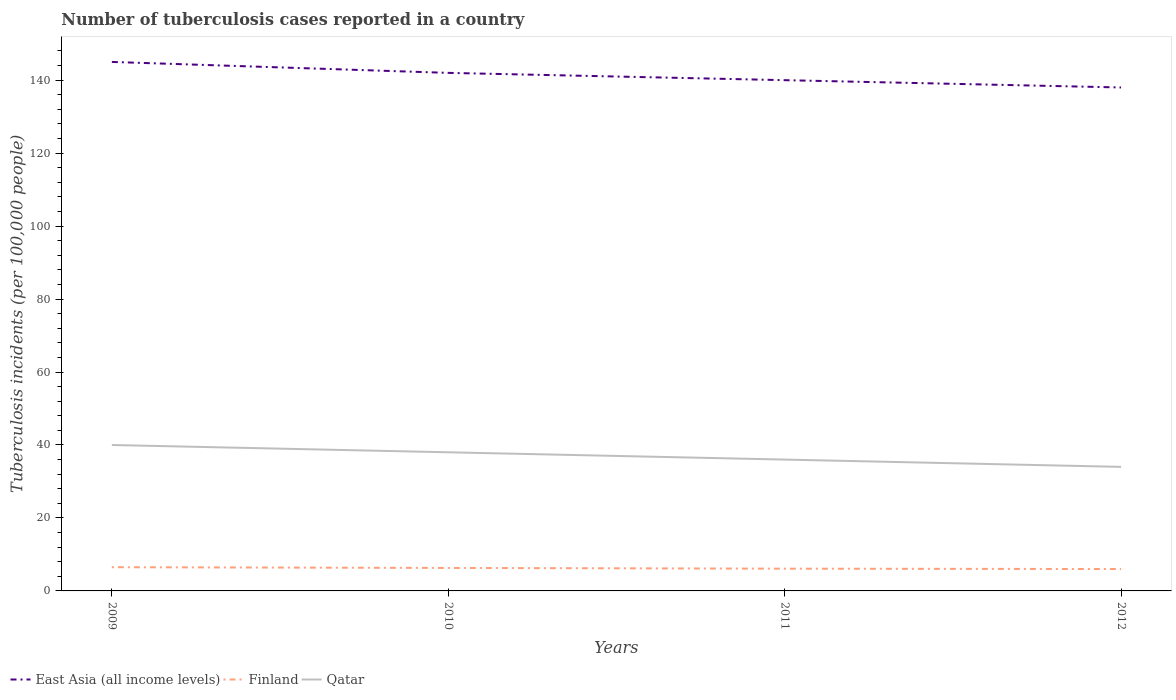Across all years, what is the maximum number of tuberculosis cases reported in in East Asia (all income levels)?
Give a very brief answer. 138. In which year was the number of tuberculosis cases reported in in Finland maximum?
Offer a very short reply. 2012. What is the difference between the highest and the second highest number of tuberculosis cases reported in in Finland?
Make the answer very short. 0.5. What is the difference between the highest and the lowest number of tuberculosis cases reported in in East Asia (all income levels)?
Provide a succinct answer. 2. How many lines are there?
Offer a very short reply. 3. Does the graph contain any zero values?
Provide a succinct answer. No. Does the graph contain grids?
Provide a succinct answer. No. Where does the legend appear in the graph?
Give a very brief answer. Bottom left. What is the title of the graph?
Your answer should be compact. Number of tuberculosis cases reported in a country. What is the label or title of the X-axis?
Keep it short and to the point. Years. What is the label or title of the Y-axis?
Offer a terse response. Tuberculosis incidents (per 100,0 people). What is the Tuberculosis incidents (per 100,000 people) of East Asia (all income levels) in 2009?
Give a very brief answer. 145. What is the Tuberculosis incidents (per 100,000 people) in Finland in 2009?
Provide a short and direct response. 6.5. What is the Tuberculosis incidents (per 100,000 people) of East Asia (all income levels) in 2010?
Your response must be concise. 142. What is the Tuberculosis incidents (per 100,000 people) of Finland in 2010?
Offer a very short reply. 6.3. What is the Tuberculosis incidents (per 100,000 people) of Qatar in 2010?
Offer a terse response. 38. What is the Tuberculosis incidents (per 100,000 people) in East Asia (all income levels) in 2011?
Give a very brief answer. 140. What is the Tuberculosis incidents (per 100,000 people) in East Asia (all income levels) in 2012?
Give a very brief answer. 138. Across all years, what is the maximum Tuberculosis incidents (per 100,000 people) in East Asia (all income levels)?
Offer a terse response. 145. Across all years, what is the maximum Tuberculosis incidents (per 100,000 people) in Qatar?
Provide a short and direct response. 40. Across all years, what is the minimum Tuberculosis incidents (per 100,000 people) of East Asia (all income levels)?
Provide a short and direct response. 138. Across all years, what is the minimum Tuberculosis incidents (per 100,000 people) of Finland?
Offer a very short reply. 6. Across all years, what is the minimum Tuberculosis incidents (per 100,000 people) of Qatar?
Keep it short and to the point. 34. What is the total Tuberculosis incidents (per 100,000 people) of East Asia (all income levels) in the graph?
Offer a very short reply. 565. What is the total Tuberculosis incidents (per 100,000 people) of Finland in the graph?
Offer a very short reply. 24.9. What is the total Tuberculosis incidents (per 100,000 people) in Qatar in the graph?
Your answer should be compact. 148. What is the difference between the Tuberculosis incidents (per 100,000 people) in Finland in 2009 and that in 2010?
Give a very brief answer. 0.2. What is the difference between the Tuberculosis incidents (per 100,000 people) of Qatar in 2009 and that in 2010?
Give a very brief answer. 2. What is the difference between the Tuberculosis incidents (per 100,000 people) in East Asia (all income levels) in 2009 and that in 2011?
Ensure brevity in your answer.  5. What is the difference between the Tuberculosis incidents (per 100,000 people) of Finland in 2009 and that in 2011?
Provide a succinct answer. 0.4. What is the difference between the Tuberculosis incidents (per 100,000 people) of Finland in 2009 and that in 2012?
Your answer should be compact. 0.5. What is the difference between the Tuberculosis incidents (per 100,000 people) in Qatar in 2009 and that in 2012?
Offer a very short reply. 6. What is the difference between the Tuberculosis incidents (per 100,000 people) in Finland in 2010 and that in 2011?
Give a very brief answer. 0.2. What is the difference between the Tuberculosis incidents (per 100,000 people) of Qatar in 2010 and that in 2011?
Your response must be concise. 2. What is the difference between the Tuberculosis incidents (per 100,000 people) of East Asia (all income levels) in 2011 and that in 2012?
Provide a short and direct response. 2. What is the difference between the Tuberculosis incidents (per 100,000 people) in Finland in 2011 and that in 2012?
Your response must be concise. 0.1. What is the difference between the Tuberculosis incidents (per 100,000 people) in Qatar in 2011 and that in 2012?
Offer a terse response. 2. What is the difference between the Tuberculosis incidents (per 100,000 people) of East Asia (all income levels) in 2009 and the Tuberculosis incidents (per 100,000 people) of Finland in 2010?
Your answer should be compact. 138.7. What is the difference between the Tuberculosis incidents (per 100,000 people) of East Asia (all income levels) in 2009 and the Tuberculosis incidents (per 100,000 people) of Qatar in 2010?
Ensure brevity in your answer.  107. What is the difference between the Tuberculosis incidents (per 100,000 people) of Finland in 2009 and the Tuberculosis incidents (per 100,000 people) of Qatar in 2010?
Keep it short and to the point. -31.5. What is the difference between the Tuberculosis incidents (per 100,000 people) in East Asia (all income levels) in 2009 and the Tuberculosis incidents (per 100,000 people) in Finland in 2011?
Provide a succinct answer. 138.9. What is the difference between the Tuberculosis incidents (per 100,000 people) in East Asia (all income levels) in 2009 and the Tuberculosis incidents (per 100,000 people) in Qatar in 2011?
Make the answer very short. 109. What is the difference between the Tuberculosis incidents (per 100,000 people) in Finland in 2009 and the Tuberculosis incidents (per 100,000 people) in Qatar in 2011?
Your answer should be compact. -29.5. What is the difference between the Tuberculosis incidents (per 100,000 people) of East Asia (all income levels) in 2009 and the Tuberculosis incidents (per 100,000 people) of Finland in 2012?
Make the answer very short. 139. What is the difference between the Tuberculosis incidents (per 100,000 people) in East Asia (all income levels) in 2009 and the Tuberculosis incidents (per 100,000 people) in Qatar in 2012?
Ensure brevity in your answer.  111. What is the difference between the Tuberculosis incidents (per 100,000 people) in Finland in 2009 and the Tuberculosis incidents (per 100,000 people) in Qatar in 2012?
Your response must be concise. -27.5. What is the difference between the Tuberculosis incidents (per 100,000 people) in East Asia (all income levels) in 2010 and the Tuberculosis incidents (per 100,000 people) in Finland in 2011?
Offer a terse response. 135.9. What is the difference between the Tuberculosis incidents (per 100,000 people) of East Asia (all income levels) in 2010 and the Tuberculosis incidents (per 100,000 people) of Qatar in 2011?
Your answer should be very brief. 106. What is the difference between the Tuberculosis incidents (per 100,000 people) in Finland in 2010 and the Tuberculosis incidents (per 100,000 people) in Qatar in 2011?
Offer a very short reply. -29.7. What is the difference between the Tuberculosis incidents (per 100,000 people) of East Asia (all income levels) in 2010 and the Tuberculosis incidents (per 100,000 people) of Finland in 2012?
Make the answer very short. 136. What is the difference between the Tuberculosis incidents (per 100,000 people) of East Asia (all income levels) in 2010 and the Tuberculosis incidents (per 100,000 people) of Qatar in 2012?
Provide a succinct answer. 108. What is the difference between the Tuberculosis incidents (per 100,000 people) of Finland in 2010 and the Tuberculosis incidents (per 100,000 people) of Qatar in 2012?
Provide a succinct answer. -27.7. What is the difference between the Tuberculosis incidents (per 100,000 people) in East Asia (all income levels) in 2011 and the Tuberculosis incidents (per 100,000 people) in Finland in 2012?
Make the answer very short. 134. What is the difference between the Tuberculosis incidents (per 100,000 people) in East Asia (all income levels) in 2011 and the Tuberculosis incidents (per 100,000 people) in Qatar in 2012?
Provide a succinct answer. 106. What is the difference between the Tuberculosis incidents (per 100,000 people) in Finland in 2011 and the Tuberculosis incidents (per 100,000 people) in Qatar in 2012?
Your answer should be compact. -27.9. What is the average Tuberculosis incidents (per 100,000 people) of East Asia (all income levels) per year?
Make the answer very short. 141.25. What is the average Tuberculosis incidents (per 100,000 people) of Finland per year?
Keep it short and to the point. 6.22. What is the average Tuberculosis incidents (per 100,000 people) in Qatar per year?
Provide a short and direct response. 37. In the year 2009, what is the difference between the Tuberculosis incidents (per 100,000 people) of East Asia (all income levels) and Tuberculosis incidents (per 100,000 people) of Finland?
Offer a very short reply. 138.5. In the year 2009, what is the difference between the Tuberculosis incidents (per 100,000 people) in East Asia (all income levels) and Tuberculosis incidents (per 100,000 people) in Qatar?
Make the answer very short. 105. In the year 2009, what is the difference between the Tuberculosis incidents (per 100,000 people) in Finland and Tuberculosis incidents (per 100,000 people) in Qatar?
Your response must be concise. -33.5. In the year 2010, what is the difference between the Tuberculosis incidents (per 100,000 people) in East Asia (all income levels) and Tuberculosis incidents (per 100,000 people) in Finland?
Provide a succinct answer. 135.7. In the year 2010, what is the difference between the Tuberculosis incidents (per 100,000 people) in East Asia (all income levels) and Tuberculosis incidents (per 100,000 people) in Qatar?
Your answer should be very brief. 104. In the year 2010, what is the difference between the Tuberculosis incidents (per 100,000 people) of Finland and Tuberculosis incidents (per 100,000 people) of Qatar?
Ensure brevity in your answer.  -31.7. In the year 2011, what is the difference between the Tuberculosis incidents (per 100,000 people) of East Asia (all income levels) and Tuberculosis incidents (per 100,000 people) of Finland?
Offer a very short reply. 133.9. In the year 2011, what is the difference between the Tuberculosis incidents (per 100,000 people) of East Asia (all income levels) and Tuberculosis incidents (per 100,000 people) of Qatar?
Offer a terse response. 104. In the year 2011, what is the difference between the Tuberculosis incidents (per 100,000 people) in Finland and Tuberculosis incidents (per 100,000 people) in Qatar?
Provide a succinct answer. -29.9. In the year 2012, what is the difference between the Tuberculosis incidents (per 100,000 people) in East Asia (all income levels) and Tuberculosis incidents (per 100,000 people) in Finland?
Provide a short and direct response. 132. In the year 2012, what is the difference between the Tuberculosis incidents (per 100,000 people) of East Asia (all income levels) and Tuberculosis incidents (per 100,000 people) of Qatar?
Provide a short and direct response. 104. What is the ratio of the Tuberculosis incidents (per 100,000 people) in East Asia (all income levels) in 2009 to that in 2010?
Provide a succinct answer. 1.02. What is the ratio of the Tuberculosis incidents (per 100,000 people) in Finland in 2009 to that in 2010?
Offer a very short reply. 1.03. What is the ratio of the Tuberculosis incidents (per 100,000 people) in Qatar in 2009 to that in 2010?
Offer a terse response. 1.05. What is the ratio of the Tuberculosis incidents (per 100,000 people) in East Asia (all income levels) in 2009 to that in 2011?
Offer a terse response. 1.04. What is the ratio of the Tuberculosis incidents (per 100,000 people) in Finland in 2009 to that in 2011?
Offer a terse response. 1.07. What is the ratio of the Tuberculosis incidents (per 100,000 people) in Qatar in 2009 to that in 2011?
Provide a short and direct response. 1.11. What is the ratio of the Tuberculosis incidents (per 100,000 people) in East Asia (all income levels) in 2009 to that in 2012?
Your answer should be compact. 1.05. What is the ratio of the Tuberculosis incidents (per 100,000 people) of Qatar in 2009 to that in 2012?
Keep it short and to the point. 1.18. What is the ratio of the Tuberculosis incidents (per 100,000 people) of East Asia (all income levels) in 2010 to that in 2011?
Your answer should be compact. 1.01. What is the ratio of the Tuberculosis incidents (per 100,000 people) of Finland in 2010 to that in 2011?
Keep it short and to the point. 1.03. What is the ratio of the Tuberculosis incidents (per 100,000 people) of Qatar in 2010 to that in 2011?
Give a very brief answer. 1.06. What is the ratio of the Tuberculosis incidents (per 100,000 people) in Finland in 2010 to that in 2012?
Keep it short and to the point. 1.05. What is the ratio of the Tuberculosis incidents (per 100,000 people) of Qatar in 2010 to that in 2012?
Make the answer very short. 1.12. What is the ratio of the Tuberculosis incidents (per 100,000 people) of East Asia (all income levels) in 2011 to that in 2012?
Your answer should be very brief. 1.01. What is the ratio of the Tuberculosis incidents (per 100,000 people) in Finland in 2011 to that in 2012?
Your answer should be very brief. 1.02. What is the ratio of the Tuberculosis incidents (per 100,000 people) in Qatar in 2011 to that in 2012?
Ensure brevity in your answer.  1.06. What is the difference between the highest and the second highest Tuberculosis incidents (per 100,000 people) of East Asia (all income levels)?
Provide a succinct answer. 3. What is the difference between the highest and the second highest Tuberculosis incidents (per 100,000 people) in Finland?
Your answer should be very brief. 0.2. What is the difference between the highest and the second highest Tuberculosis incidents (per 100,000 people) in Qatar?
Keep it short and to the point. 2. 